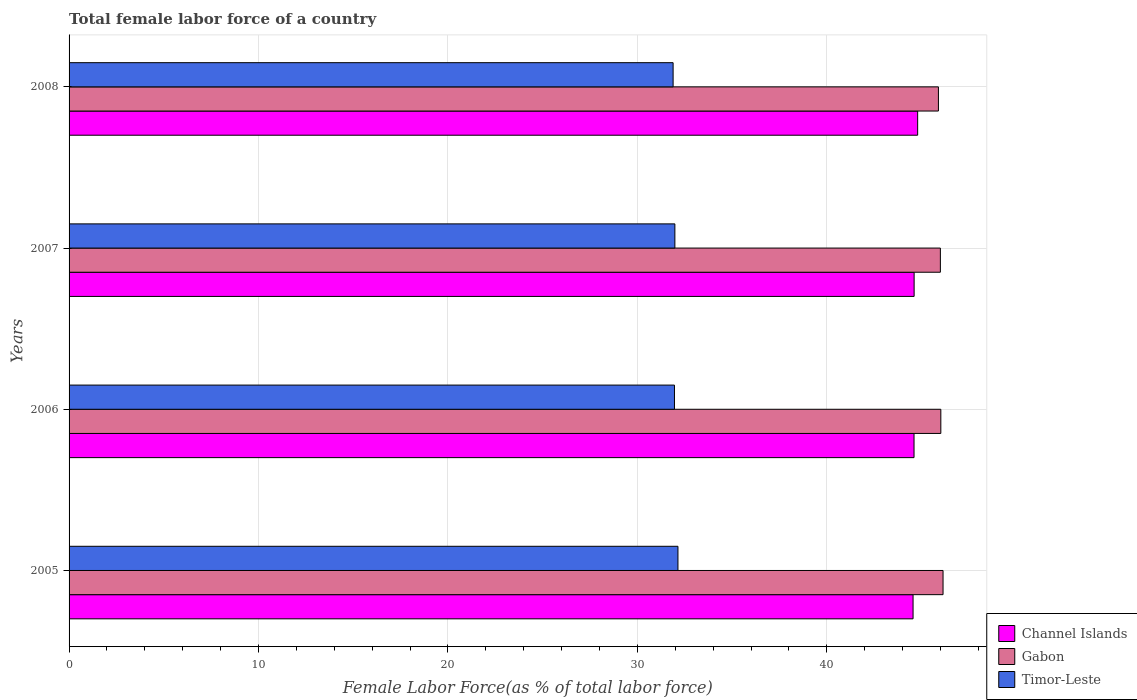Are the number of bars per tick equal to the number of legend labels?
Provide a succinct answer. Yes. In how many cases, is the number of bars for a given year not equal to the number of legend labels?
Offer a very short reply. 0. What is the percentage of female labor force in Channel Islands in 2008?
Keep it short and to the point. 44.79. Across all years, what is the maximum percentage of female labor force in Channel Islands?
Keep it short and to the point. 44.79. Across all years, what is the minimum percentage of female labor force in Channel Islands?
Provide a succinct answer. 44.55. In which year was the percentage of female labor force in Timor-Leste maximum?
Your answer should be very brief. 2005. What is the total percentage of female labor force in Timor-Leste in the graph?
Offer a very short reply. 127.96. What is the difference between the percentage of female labor force in Channel Islands in 2007 and that in 2008?
Your answer should be very brief. -0.19. What is the difference between the percentage of female labor force in Gabon in 2006 and the percentage of female labor force in Timor-Leste in 2005?
Provide a succinct answer. 13.88. What is the average percentage of female labor force in Channel Islands per year?
Provide a short and direct response. 44.64. In the year 2007, what is the difference between the percentage of female labor force in Timor-Leste and percentage of female labor force in Channel Islands?
Provide a succinct answer. -12.63. In how many years, is the percentage of female labor force in Gabon greater than 2 %?
Make the answer very short. 4. What is the ratio of the percentage of female labor force in Channel Islands in 2007 to that in 2008?
Keep it short and to the point. 1. Is the difference between the percentage of female labor force in Timor-Leste in 2005 and 2008 greater than the difference between the percentage of female labor force in Channel Islands in 2005 and 2008?
Your answer should be very brief. Yes. What is the difference between the highest and the second highest percentage of female labor force in Timor-Leste?
Provide a succinct answer. 0.16. What is the difference between the highest and the lowest percentage of female labor force in Timor-Leste?
Give a very brief answer. 0.26. In how many years, is the percentage of female labor force in Gabon greater than the average percentage of female labor force in Gabon taken over all years?
Ensure brevity in your answer.  2. Is the sum of the percentage of female labor force in Channel Islands in 2007 and 2008 greater than the maximum percentage of female labor force in Timor-Leste across all years?
Provide a succinct answer. Yes. What does the 2nd bar from the top in 2005 represents?
Your answer should be compact. Gabon. What does the 3rd bar from the bottom in 2005 represents?
Offer a terse response. Timor-Leste. What is the difference between two consecutive major ticks on the X-axis?
Give a very brief answer. 10. Does the graph contain grids?
Keep it short and to the point. Yes. How many legend labels are there?
Offer a terse response. 3. How are the legend labels stacked?
Keep it short and to the point. Vertical. What is the title of the graph?
Give a very brief answer. Total female labor force of a country. Does "Syrian Arab Republic" appear as one of the legend labels in the graph?
Provide a succinct answer. No. What is the label or title of the X-axis?
Your response must be concise. Female Labor Force(as % of total labor force). What is the Female Labor Force(as % of total labor force) in Channel Islands in 2005?
Offer a terse response. 44.55. What is the Female Labor Force(as % of total labor force) in Gabon in 2005?
Offer a terse response. 46.13. What is the Female Labor Force(as % of total labor force) of Timor-Leste in 2005?
Give a very brief answer. 32.14. What is the Female Labor Force(as % of total labor force) of Channel Islands in 2006?
Give a very brief answer. 44.6. What is the Female Labor Force(as % of total labor force) in Gabon in 2006?
Provide a succinct answer. 46.02. What is the Female Labor Force(as % of total labor force) in Timor-Leste in 2006?
Provide a succinct answer. 31.96. What is the Female Labor Force(as % of total labor force) in Channel Islands in 2007?
Your answer should be very brief. 44.61. What is the Female Labor Force(as % of total labor force) of Gabon in 2007?
Keep it short and to the point. 45.99. What is the Female Labor Force(as % of total labor force) of Timor-Leste in 2007?
Offer a terse response. 31.98. What is the Female Labor Force(as % of total labor force) of Channel Islands in 2008?
Ensure brevity in your answer.  44.79. What is the Female Labor Force(as % of total labor force) in Gabon in 2008?
Your answer should be compact. 45.89. What is the Female Labor Force(as % of total labor force) of Timor-Leste in 2008?
Give a very brief answer. 31.89. Across all years, what is the maximum Female Labor Force(as % of total labor force) of Channel Islands?
Provide a short and direct response. 44.79. Across all years, what is the maximum Female Labor Force(as % of total labor force) of Gabon?
Keep it short and to the point. 46.13. Across all years, what is the maximum Female Labor Force(as % of total labor force) in Timor-Leste?
Offer a terse response. 32.14. Across all years, what is the minimum Female Labor Force(as % of total labor force) in Channel Islands?
Provide a succinct answer. 44.55. Across all years, what is the minimum Female Labor Force(as % of total labor force) in Gabon?
Your response must be concise. 45.89. Across all years, what is the minimum Female Labor Force(as % of total labor force) of Timor-Leste?
Keep it short and to the point. 31.89. What is the total Female Labor Force(as % of total labor force) in Channel Islands in the graph?
Offer a terse response. 178.56. What is the total Female Labor Force(as % of total labor force) of Gabon in the graph?
Give a very brief answer. 184.04. What is the total Female Labor Force(as % of total labor force) of Timor-Leste in the graph?
Your answer should be very brief. 127.96. What is the difference between the Female Labor Force(as % of total labor force) in Channel Islands in 2005 and that in 2006?
Offer a very short reply. -0.05. What is the difference between the Female Labor Force(as % of total labor force) of Gabon in 2005 and that in 2006?
Your answer should be very brief. 0.12. What is the difference between the Female Labor Force(as % of total labor force) in Timor-Leste in 2005 and that in 2006?
Offer a terse response. 0.18. What is the difference between the Female Labor Force(as % of total labor force) of Channel Islands in 2005 and that in 2007?
Your answer should be compact. -0.06. What is the difference between the Female Labor Force(as % of total labor force) of Gabon in 2005 and that in 2007?
Offer a terse response. 0.14. What is the difference between the Female Labor Force(as % of total labor force) of Timor-Leste in 2005 and that in 2007?
Ensure brevity in your answer.  0.16. What is the difference between the Female Labor Force(as % of total labor force) of Channel Islands in 2005 and that in 2008?
Offer a very short reply. -0.24. What is the difference between the Female Labor Force(as % of total labor force) in Gabon in 2005 and that in 2008?
Give a very brief answer. 0.24. What is the difference between the Female Labor Force(as % of total labor force) in Timor-Leste in 2005 and that in 2008?
Your answer should be very brief. 0.26. What is the difference between the Female Labor Force(as % of total labor force) of Channel Islands in 2006 and that in 2007?
Provide a short and direct response. -0.01. What is the difference between the Female Labor Force(as % of total labor force) in Gabon in 2006 and that in 2007?
Ensure brevity in your answer.  0.02. What is the difference between the Female Labor Force(as % of total labor force) in Timor-Leste in 2006 and that in 2007?
Keep it short and to the point. -0.02. What is the difference between the Female Labor Force(as % of total labor force) of Channel Islands in 2006 and that in 2008?
Your response must be concise. -0.19. What is the difference between the Female Labor Force(as % of total labor force) of Gabon in 2006 and that in 2008?
Provide a succinct answer. 0.13. What is the difference between the Female Labor Force(as % of total labor force) of Timor-Leste in 2006 and that in 2008?
Ensure brevity in your answer.  0.07. What is the difference between the Female Labor Force(as % of total labor force) of Channel Islands in 2007 and that in 2008?
Make the answer very short. -0.19. What is the difference between the Female Labor Force(as % of total labor force) of Gabon in 2007 and that in 2008?
Ensure brevity in your answer.  0.1. What is the difference between the Female Labor Force(as % of total labor force) of Timor-Leste in 2007 and that in 2008?
Ensure brevity in your answer.  0.09. What is the difference between the Female Labor Force(as % of total labor force) in Channel Islands in 2005 and the Female Labor Force(as % of total labor force) in Gabon in 2006?
Ensure brevity in your answer.  -1.47. What is the difference between the Female Labor Force(as % of total labor force) of Channel Islands in 2005 and the Female Labor Force(as % of total labor force) of Timor-Leste in 2006?
Your answer should be very brief. 12.59. What is the difference between the Female Labor Force(as % of total labor force) in Gabon in 2005 and the Female Labor Force(as % of total labor force) in Timor-Leste in 2006?
Make the answer very short. 14.18. What is the difference between the Female Labor Force(as % of total labor force) of Channel Islands in 2005 and the Female Labor Force(as % of total labor force) of Gabon in 2007?
Offer a terse response. -1.44. What is the difference between the Female Labor Force(as % of total labor force) of Channel Islands in 2005 and the Female Labor Force(as % of total labor force) of Timor-Leste in 2007?
Offer a very short reply. 12.57. What is the difference between the Female Labor Force(as % of total labor force) in Gabon in 2005 and the Female Labor Force(as % of total labor force) in Timor-Leste in 2007?
Provide a short and direct response. 14.16. What is the difference between the Female Labor Force(as % of total labor force) of Channel Islands in 2005 and the Female Labor Force(as % of total labor force) of Gabon in 2008?
Your response must be concise. -1.34. What is the difference between the Female Labor Force(as % of total labor force) of Channel Islands in 2005 and the Female Labor Force(as % of total labor force) of Timor-Leste in 2008?
Make the answer very short. 12.67. What is the difference between the Female Labor Force(as % of total labor force) in Gabon in 2005 and the Female Labor Force(as % of total labor force) in Timor-Leste in 2008?
Offer a terse response. 14.25. What is the difference between the Female Labor Force(as % of total labor force) of Channel Islands in 2006 and the Female Labor Force(as % of total labor force) of Gabon in 2007?
Give a very brief answer. -1.39. What is the difference between the Female Labor Force(as % of total labor force) in Channel Islands in 2006 and the Female Labor Force(as % of total labor force) in Timor-Leste in 2007?
Your answer should be very brief. 12.62. What is the difference between the Female Labor Force(as % of total labor force) of Gabon in 2006 and the Female Labor Force(as % of total labor force) of Timor-Leste in 2007?
Provide a succinct answer. 14.04. What is the difference between the Female Labor Force(as % of total labor force) in Channel Islands in 2006 and the Female Labor Force(as % of total labor force) in Gabon in 2008?
Keep it short and to the point. -1.29. What is the difference between the Female Labor Force(as % of total labor force) of Channel Islands in 2006 and the Female Labor Force(as % of total labor force) of Timor-Leste in 2008?
Your answer should be compact. 12.72. What is the difference between the Female Labor Force(as % of total labor force) of Gabon in 2006 and the Female Labor Force(as % of total labor force) of Timor-Leste in 2008?
Keep it short and to the point. 14.13. What is the difference between the Female Labor Force(as % of total labor force) of Channel Islands in 2007 and the Female Labor Force(as % of total labor force) of Gabon in 2008?
Your answer should be compact. -1.28. What is the difference between the Female Labor Force(as % of total labor force) in Channel Islands in 2007 and the Female Labor Force(as % of total labor force) in Timor-Leste in 2008?
Offer a very short reply. 12.72. What is the difference between the Female Labor Force(as % of total labor force) of Gabon in 2007 and the Female Labor Force(as % of total labor force) of Timor-Leste in 2008?
Keep it short and to the point. 14.11. What is the average Female Labor Force(as % of total labor force) in Channel Islands per year?
Ensure brevity in your answer.  44.64. What is the average Female Labor Force(as % of total labor force) in Gabon per year?
Offer a terse response. 46.01. What is the average Female Labor Force(as % of total labor force) of Timor-Leste per year?
Your answer should be very brief. 31.99. In the year 2005, what is the difference between the Female Labor Force(as % of total labor force) of Channel Islands and Female Labor Force(as % of total labor force) of Gabon?
Offer a very short reply. -1.58. In the year 2005, what is the difference between the Female Labor Force(as % of total labor force) of Channel Islands and Female Labor Force(as % of total labor force) of Timor-Leste?
Your response must be concise. 12.41. In the year 2005, what is the difference between the Female Labor Force(as % of total labor force) of Gabon and Female Labor Force(as % of total labor force) of Timor-Leste?
Your answer should be compact. 13.99. In the year 2006, what is the difference between the Female Labor Force(as % of total labor force) in Channel Islands and Female Labor Force(as % of total labor force) in Gabon?
Provide a short and direct response. -1.41. In the year 2006, what is the difference between the Female Labor Force(as % of total labor force) in Channel Islands and Female Labor Force(as % of total labor force) in Timor-Leste?
Your response must be concise. 12.65. In the year 2006, what is the difference between the Female Labor Force(as % of total labor force) of Gabon and Female Labor Force(as % of total labor force) of Timor-Leste?
Offer a very short reply. 14.06. In the year 2007, what is the difference between the Female Labor Force(as % of total labor force) in Channel Islands and Female Labor Force(as % of total labor force) in Gabon?
Your answer should be compact. -1.39. In the year 2007, what is the difference between the Female Labor Force(as % of total labor force) of Channel Islands and Female Labor Force(as % of total labor force) of Timor-Leste?
Ensure brevity in your answer.  12.63. In the year 2007, what is the difference between the Female Labor Force(as % of total labor force) of Gabon and Female Labor Force(as % of total labor force) of Timor-Leste?
Give a very brief answer. 14.01. In the year 2008, what is the difference between the Female Labor Force(as % of total labor force) in Channel Islands and Female Labor Force(as % of total labor force) in Gabon?
Make the answer very short. -1.1. In the year 2008, what is the difference between the Female Labor Force(as % of total labor force) in Channel Islands and Female Labor Force(as % of total labor force) in Timor-Leste?
Give a very brief answer. 12.91. In the year 2008, what is the difference between the Female Labor Force(as % of total labor force) in Gabon and Female Labor Force(as % of total labor force) in Timor-Leste?
Provide a short and direct response. 14.01. What is the ratio of the Female Labor Force(as % of total labor force) in Channel Islands in 2005 to that in 2006?
Offer a very short reply. 1. What is the ratio of the Female Labor Force(as % of total labor force) of Gabon in 2005 to that in 2006?
Provide a short and direct response. 1. What is the ratio of the Female Labor Force(as % of total labor force) of Timor-Leste in 2005 to that in 2006?
Your response must be concise. 1.01. What is the ratio of the Female Labor Force(as % of total labor force) of Gabon in 2005 to that in 2007?
Your answer should be compact. 1. What is the ratio of the Female Labor Force(as % of total labor force) of Timor-Leste in 2005 to that in 2007?
Ensure brevity in your answer.  1.01. What is the ratio of the Female Labor Force(as % of total labor force) in Channel Islands in 2005 to that in 2008?
Your response must be concise. 0.99. What is the ratio of the Female Labor Force(as % of total labor force) of Timor-Leste in 2005 to that in 2008?
Provide a short and direct response. 1.01. What is the ratio of the Female Labor Force(as % of total labor force) of Channel Islands in 2006 to that in 2007?
Provide a succinct answer. 1. What is the ratio of the Female Labor Force(as % of total labor force) in Gabon in 2006 to that in 2007?
Provide a short and direct response. 1. What is the ratio of the Female Labor Force(as % of total labor force) of Gabon in 2006 to that in 2008?
Offer a terse response. 1. What is the ratio of the Female Labor Force(as % of total labor force) in Gabon in 2007 to that in 2008?
Ensure brevity in your answer.  1. What is the difference between the highest and the second highest Female Labor Force(as % of total labor force) of Channel Islands?
Your answer should be very brief. 0.19. What is the difference between the highest and the second highest Female Labor Force(as % of total labor force) in Gabon?
Your answer should be very brief. 0.12. What is the difference between the highest and the second highest Female Labor Force(as % of total labor force) of Timor-Leste?
Your answer should be very brief. 0.16. What is the difference between the highest and the lowest Female Labor Force(as % of total labor force) in Channel Islands?
Keep it short and to the point. 0.24. What is the difference between the highest and the lowest Female Labor Force(as % of total labor force) in Gabon?
Provide a succinct answer. 0.24. What is the difference between the highest and the lowest Female Labor Force(as % of total labor force) of Timor-Leste?
Your answer should be very brief. 0.26. 